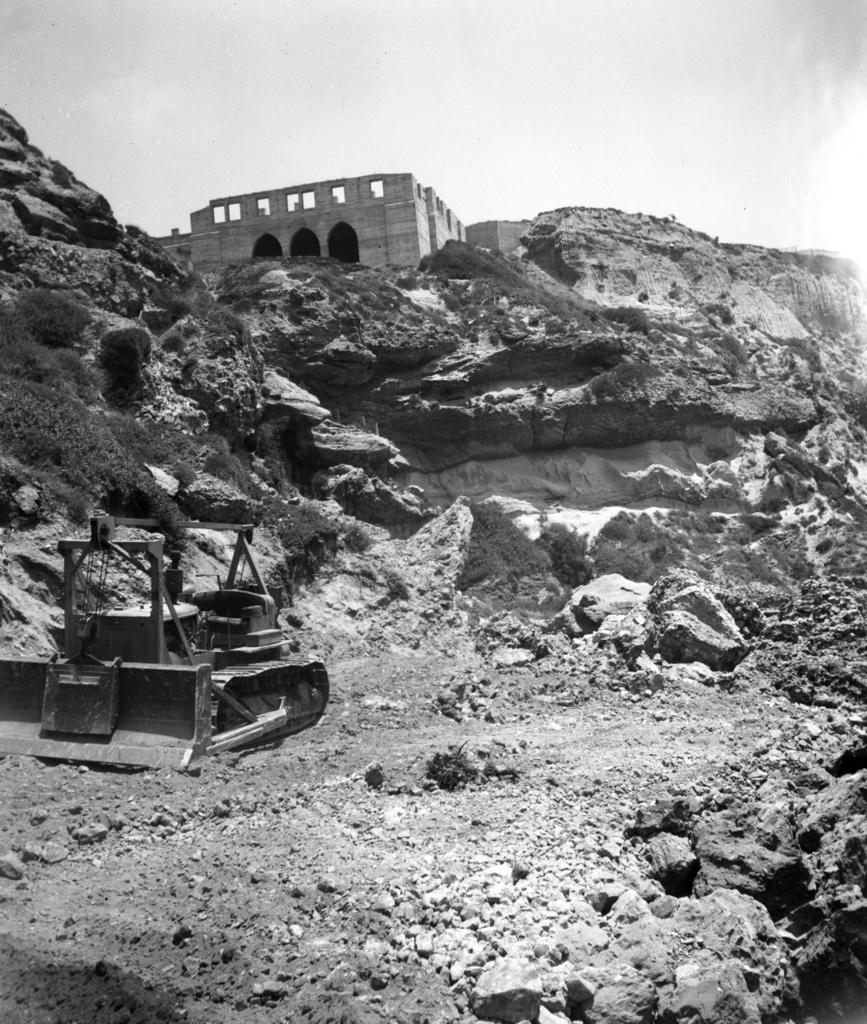Could you give a brief overview of what you see in this image? This is a black and white image, in this image on the left side there is one vehicle, and at the bottom there are some rocks and some sand. And in the background there are mountains and building, at the top there is sky. 